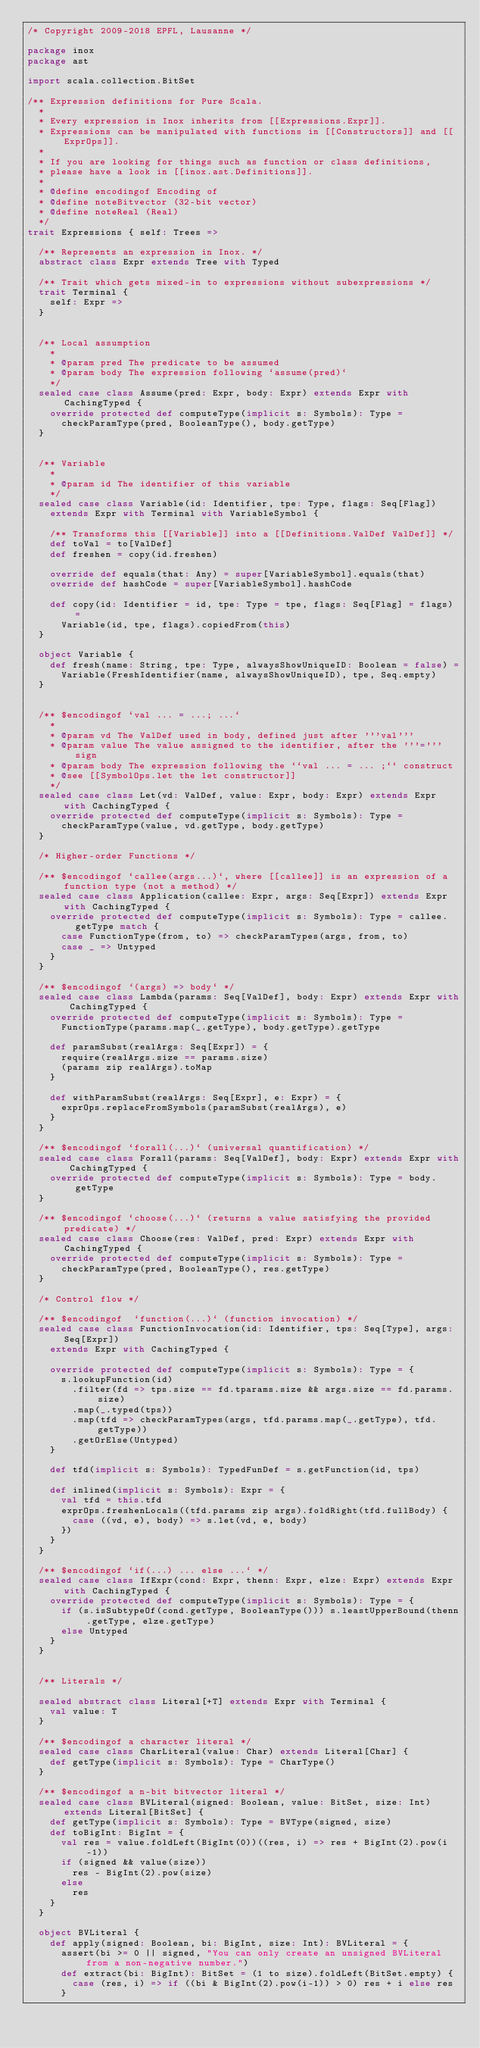<code> <loc_0><loc_0><loc_500><loc_500><_Scala_>/* Copyright 2009-2018 EPFL, Lausanne */

package inox
package ast

import scala.collection.BitSet

/** Expression definitions for Pure Scala.
  *
  * Every expression in Inox inherits from [[Expressions.Expr]].
  * Expressions can be manipulated with functions in [[Constructors]] and [[ExprOps]].
  *
  * If you are looking for things such as function or class definitions,
  * please have a look in [[inox.ast.Definitions]].
  *
  * @define encodingof Encoding of
  * @define noteBitvector (32-bit vector)
  * @define noteReal (Real)
  */
trait Expressions { self: Trees =>

  /** Represents an expression in Inox. */
  abstract class Expr extends Tree with Typed

  /** Trait which gets mixed-in to expressions without subexpressions */
  trait Terminal {
    self: Expr =>
  }


  /** Local assumption
    *
    * @param pred The predicate to be assumed
    * @param body The expression following `assume(pred)`
    */
  sealed case class Assume(pred: Expr, body: Expr) extends Expr with CachingTyped {
    override protected def computeType(implicit s: Symbols): Type =
      checkParamType(pred, BooleanType(), body.getType)
  }


  /** Variable
    *
    * @param id The identifier of this variable
    */
  sealed case class Variable(id: Identifier, tpe: Type, flags: Seq[Flag])
    extends Expr with Terminal with VariableSymbol {

    /** Transforms this [[Variable]] into a [[Definitions.ValDef ValDef]] */
    def toVal = to[ValDef]
    def freshen = copy(id.freshen)

    override def equals(that: Any) = super[VariableSymbol].equals(that)
    override def hashCode = super[VariableSymbol].hashCode

    def copy(id: Identifier = id, tpe: Type = tpe, flags: Seq[Flag] = flags) =
      Variable(id, tpe, flags).copiedFrom(this)
  }

  object Variable {
    def fresh(name: String, tpe: Type, alwaysShowUniqueID: Boolean = false) =
      Variable(FreshIdentifier(name, alwaysShowUniqueID), tpe, Seq.empty)
  }


  /** $encodingof `val ... = ...; ...`
    *
    * @param vd The ValDef used in body, defined just after '''val'''
    * @param value The value assigned to the identifier, after the '''=''' sign
    * @param body The expression following the ``val ... = ... ;`` construct
    * @see [[SymbolOps.let the let constructor]]
    */
  sealed case class Let(vd: ValDef, value: Expr, body: Expr) extends Expr with CachingTyped {
    override protected def computeType(implicit s: Symbols): Type =
      checkParamType(value, vd.getType, body.getType)
  }

  /* Higher-order Functions */

  /** $encodingof `callee(args...)`, where [[callee]] is an expression of a function type (not a method) */
  sealed case class Application(callee: Expr, args: Seq[Expr]) extends Expr with CachingTyped {
    override protected def computeType(implicit s: Symbols): Type = callee.getType match {
      case FunctionType(from, to) => checkParamTypes(args, from, to)
      case _ => Untyped
    }
  }

  /** $encodingof `(args) => body` */
  sealed case class Lambda(params: Seq[ValDef], body: Expr) extends Expr with CachingTyped {
    override protected def computeType(implicit s: Symbols): Type =
      FunctionType(params.map(_.getType), body.getType).getType

    def paramSubst(realArgs: Seq[Expr]) = {
      require(realArgs.size == params.size)
      (params zip realArgs).toMap
    }

    def withParamSubst(realArgs: Seq[Expr], e: Expr) = {
      exprOps.replaceFromSymbols(paramSubst(realArgs), e)
    }
  }

  /** $encodingof `forall(...)` (universal quantification) */
  sealed case class Forall(params: Seq[ValDef], body: Expr) extends Expr with CachingTyped {
    override protected def computeType(implicit s: Symbols): Type = body.getType
  }

  /** $encodingof `choose(...)` (returns a value satisfying the provided predicate) */
  sealed case class Choose(res: ValDef, pred: Expr) extends Expr with CachingTyped {
    override protected def computeType(implicit s: Symbols): Type =
      checkParamType(pred, BooleanType(), res.getType)
  }

  /* Control flow */

  /** $encodingof  `function(...)` (function invocation) */
  sealed case class FunctionInvocation(id: Identifier, tps: Seq[Type], args: Seq[Expr])
    extends Expr with CachingTyped {

    override protected def computeType(implicit s: Symbols): Type = {
      s.lookupFunction(id)
        .filter(fd => tps.size == fd.tparams.size && args.size == fd.params.size)
        .map(_.typed(tps))
        .map(tfd => checkParamTypes(args, tfd.params.map(_.getType), tfd.getType))
        .getOrElse(Untyped)
    }

    def tfd(implicit s: Symbols): TypedFunDef = s.getFunction(id, tps)

    def inlined(implicit s: Symbols): Expr = {
      val tfd = this.tfd
      exprOps.freshenLocals((tfd.params zip args).foldRight(tfd.fullBody) {
        case ((vd, e), body) => s.let(vd, e, body)
      })
    }
  }

  /** $encodingof `if(...) ... else ...` */
  sealed case class IfExpr(cond: Expr, thenn: Expr, elze: Expr) extends Expr with CachingTyped {
    override protected def computeType(implicit s: Symbols): Type = {
      if (s.isSubtypeOf(cond.getType, BooleanType())) s.leastUpperBound(thenn.getType, elze.getType)
      else Untyped
    }
  }


  /** Literals */

  sealed abstract class Literal[+T] extends Expr with Terminal {
    val value: T
  }

  /** $encodingof a character literal */
  sealed case class CharLiteral(value: Char) extends Literal[Char] {
    def getType(implicit s: Symbols): Type = CharType()
  }

  /** $encodingof a n-bit bitvector literal */
  sealed case class BVLiteral(signed: Boolean, value: BitSet, size: Int) extends Literal[BitSet] {
    def getType(implicit s: Symbols): Type = BVType(signed, size)
    def toBigInt: BigInt = {
      val res = value.foldLeft(BigInt(0))((res, i) => res + BigInt(2).pow(i-1))
      if (signed && value(size)) 
        res - BigInt(2).pow(size) 
      else 
        res
    }
  }

  object BVLiteral {
    def apply(signed: Boolean, bi: BigInt, size: Int): BVLiteral = {
      assert(bi >= 0 || signed, "You can only create an unsigned BVLiteral from a non-negative number.")
      def extract(bi: BigInt): BitSet = (1 to size).foldLeft(BitSet.empty) {
        case (res, i) => if ((bi & BigInt(2).pow(i-1)) > 0) res + i else res
      }
</code> 